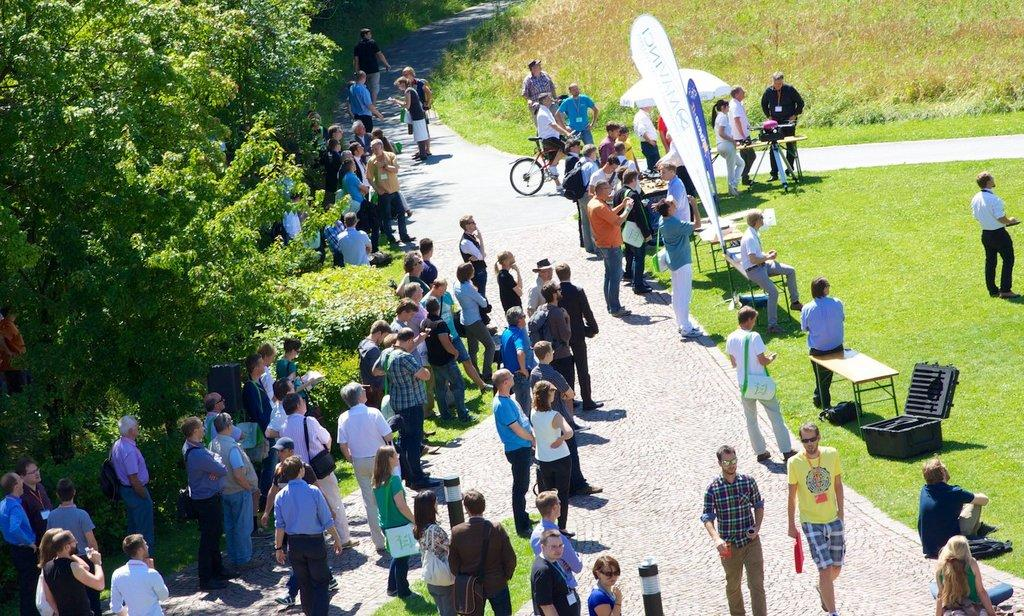How many people are present in the image? There are many people standing in the image. What object can be seen providing shade in the image? There is an umbrella in the image. What type of signage is visible in the image? There is a banner in the image. What type of surface is underfoot in the image? There is grass on the floor in the image. What type of vegetation is present in the image? There are trees in the image. What is the condition of the sky in the image? The sky is clear in the image. How many boys are ploughing the field in the image? There is no mention of boys or ploughing in the image; it features many people, an umbrella, a banner, grass, trees, and a clear sky. 